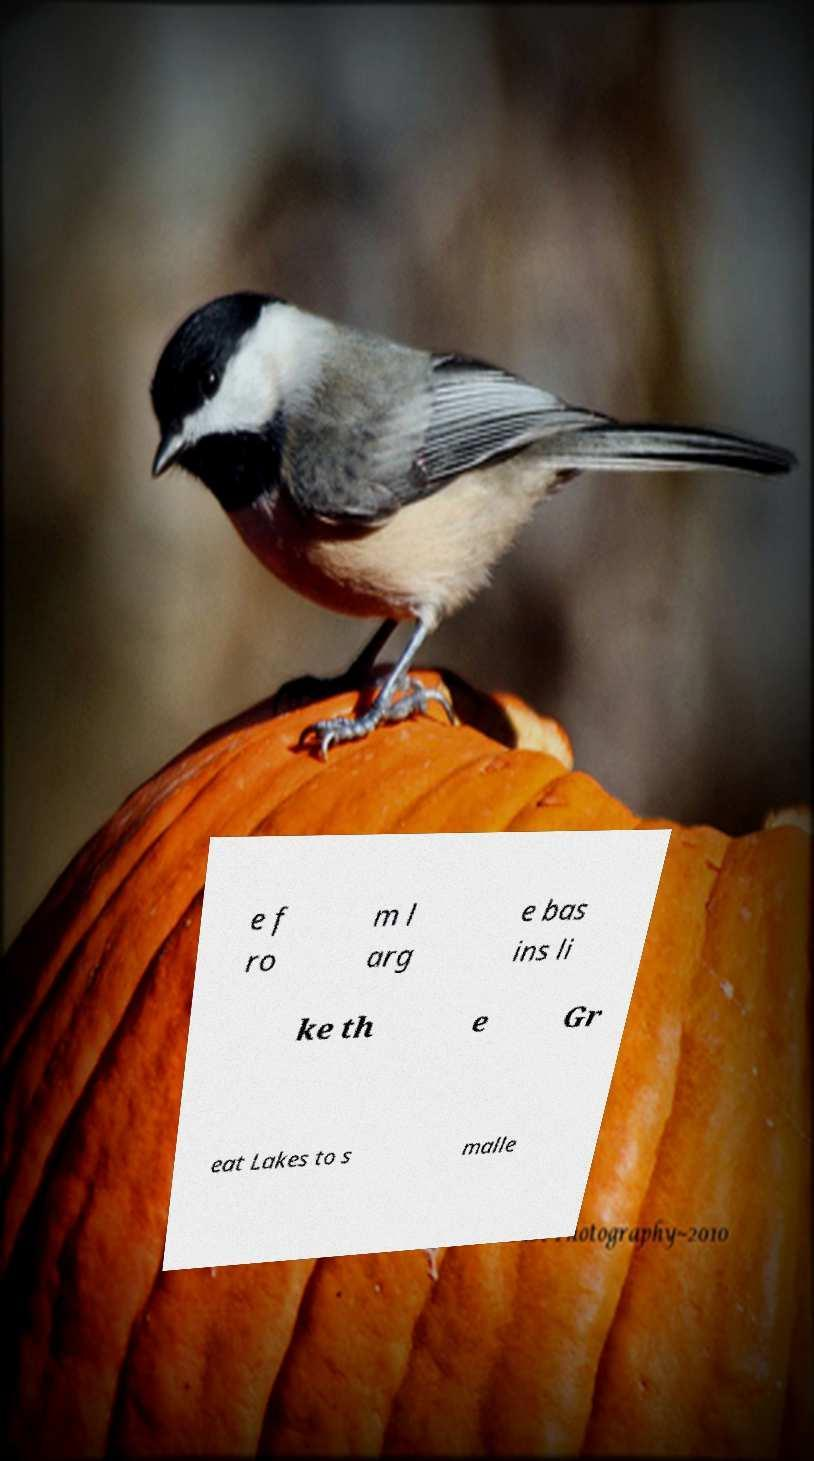I need the written content from this picture converted into text. Can you do that? e f ro m l arg e bas ins li ke th e Gr eat Lakes to s malle 